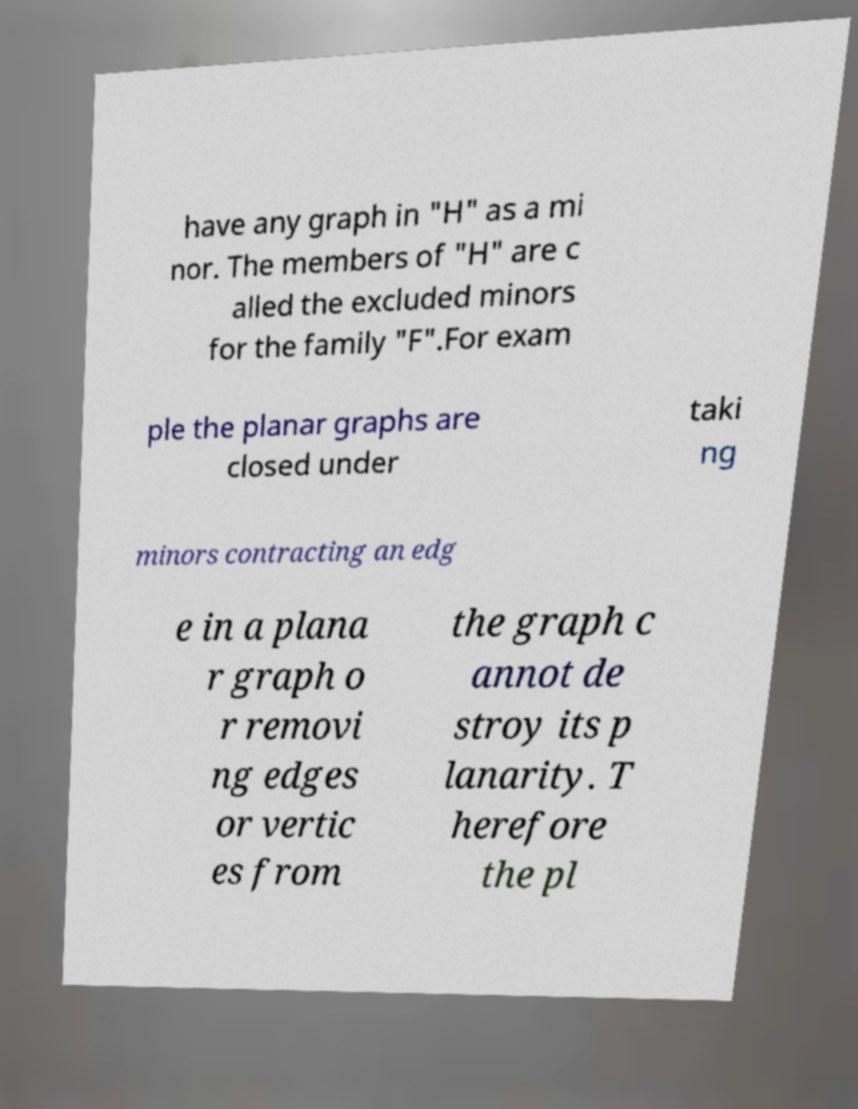Can you accurately transcribe the text from the provided image for me? have any graph in "H" as a mi nor. The members of "H" are c alled the excluded minors for the family "F".For exam ple the planar graphs are closed under taki ng minors contracting an edg e in a plana r graph o r removi ng edges or vertic es from the graph c annot de stroy its p lanarity. T herefore the pl 